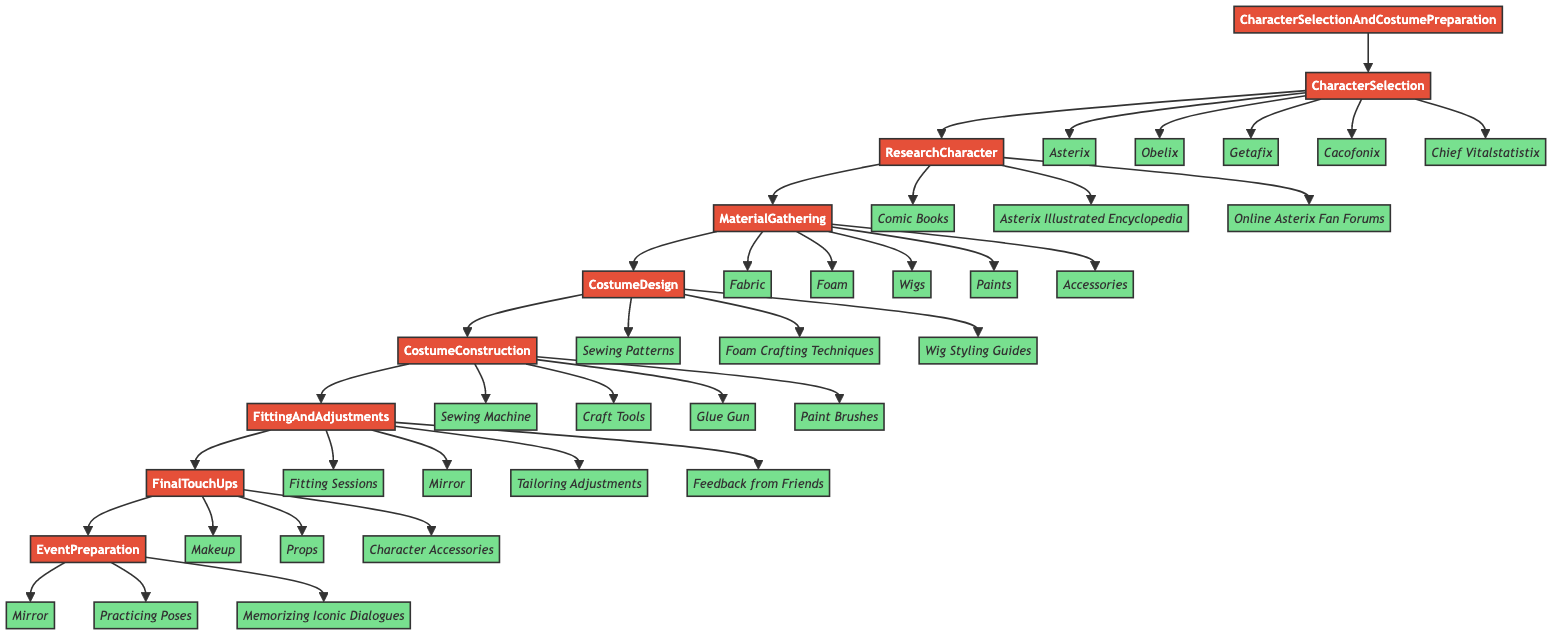What is the first step in the process? The flowchart starts with the node labeled "CharacterSelection," which indicates that selecting a character is the initial task in the workflow.
Answer: CharacterSelection How many characters can be selected? The "CharacterSelection" step lists five distinct options: Asterix, Obelix, Getafix, Cacofonix, and Chief Vitalstatistix, making it a total of five characters.
Answer: 5 Which step follows 'MaterialGathering'? After the "MaterialGathering" step, the flowchart leads to "CostumeDesign," indicating that design work follows material collection.
Answer: CostumeDesign What type of entities are listed under 'FinalTouchUps'? In the "FinalTouchUps" step, the entities provided are "Makeup," "Props," and "Character Accessories," which are all items used for enhancing the costume.
Answer: Makeup, Props, Character Accessories What is the relationship between 'ResearchCharacter' and 'MaterialGathering'? “ResearchCharacter” is a prerequisite for “MaterialGathering,” meaning that the research must be completed before gathering materials for the costume, establishing a sequential relationship.
Answer: Sequential What materials are needed for 'CostumeConstruction'? The "CostumeConstruction" step identifies four entities: Sewing Machine, Craft Tools, Glue Gun, and Paint Brushes, all of which are necessary for constructing the costume.
Answer: Sewing Machine, Craft Tools, Glue Gun, Paint Brushes What are the entities involved in 'EventPreparation'? The "EventPreparation" step includes three entities: Mirror, Practicing Poses, and Memorizing Iconic Dialogues, all of which contribute to preparation for the cosplay event.
Answer: Mirror, Practicing Poses, Memorizing Iconic Dialogues How many steps are there in total? The diagram consists of eight main steps, starting from "CharacterSelection" and ending with "EventPreparation," thereby totaling eight steps in the process.
Answer: 8 What is involved in the 'FittingAndAdjustments' step? The "FittingAndAdjustments" step comprises four entities: Fitting Sessions, Mirror, Tailoring Adjustments, and Feedback from Friends, which are all part of ensuring the costume is comfortable and accurate.
Answer: Fitting Sessions, Mirror, Tailoring Adjustments, Feedback from Friends 